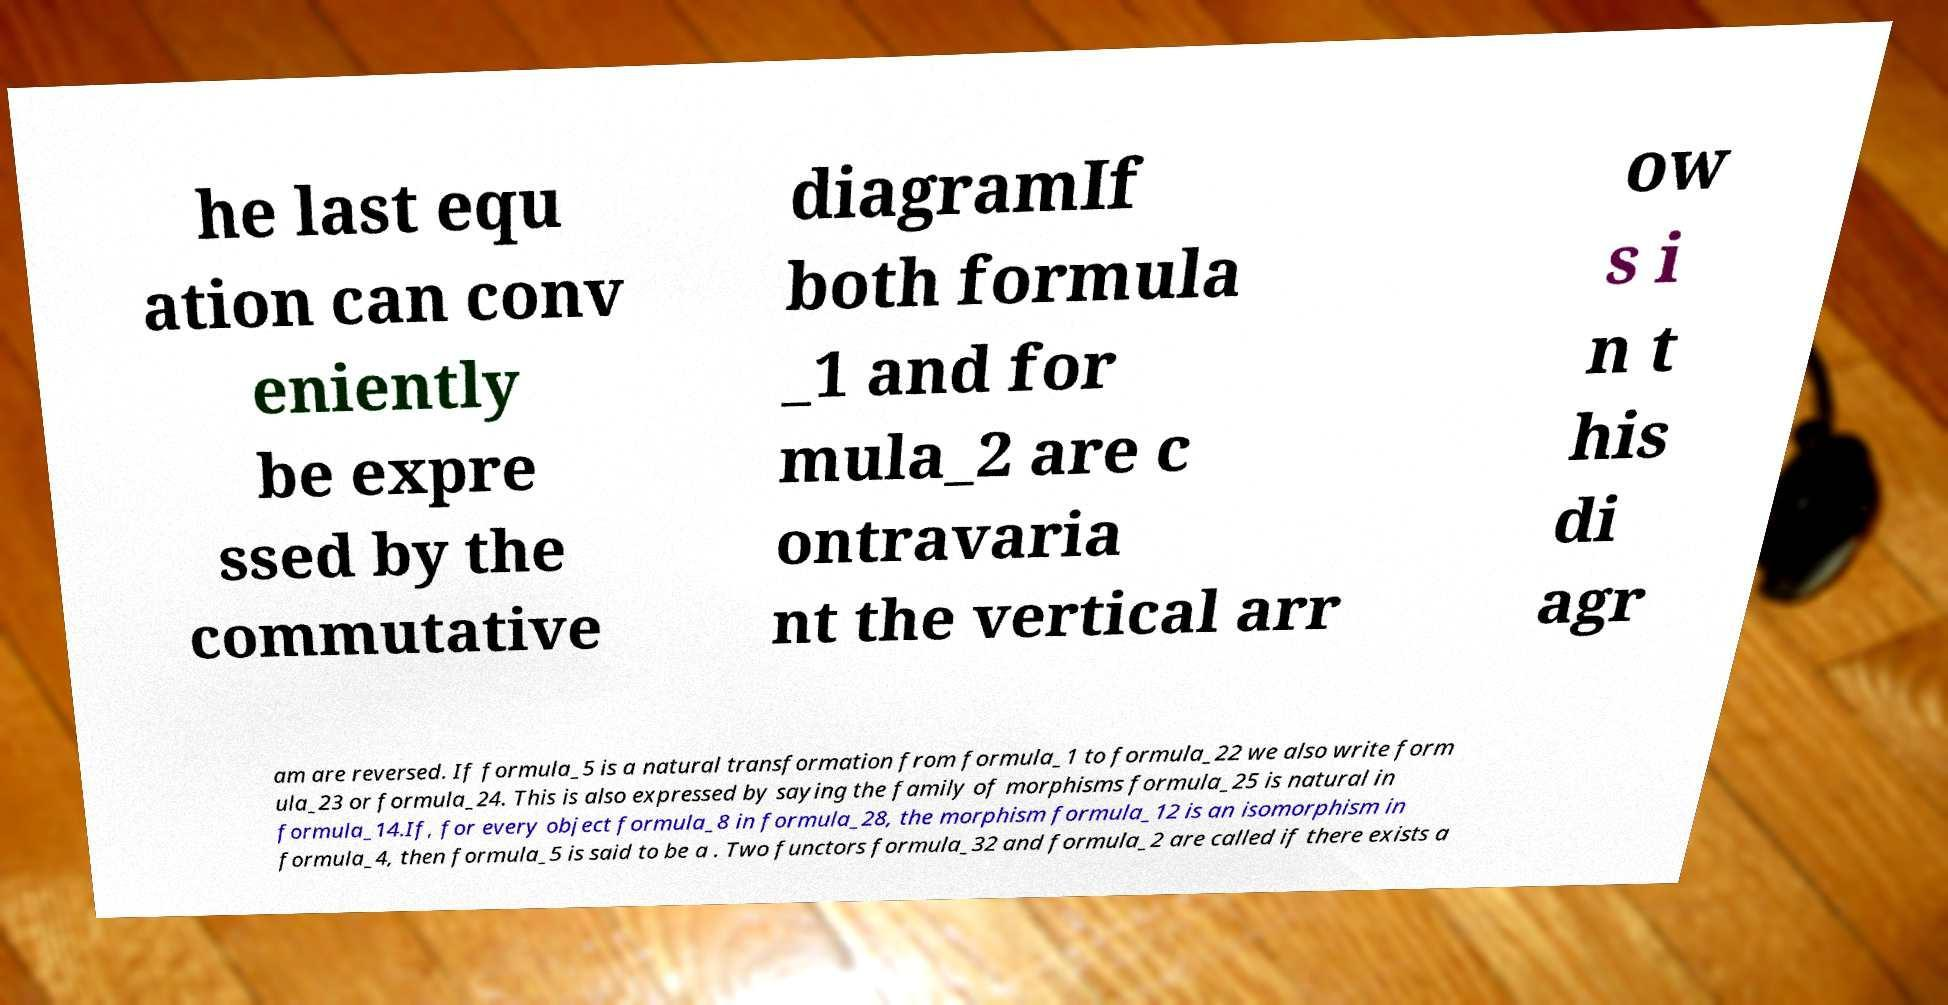Could you extract and type out the text from this image? he last equ ation can conv eniently be expre ssed by the commutative diagramIf both formula _1 and for mula_2 are c ontravaria nt the vertical arr ow s i n t his di agr am are reversed. If formula_5 is a natural transformation from formula_1 to formula_22 we also write form ula_23 or formula_24. This is also expressed by saying the family of morphisms formula_25 is natural in formula_14.If, for every object formula_8 in formula_28, the morphism formula_12 is an isomorphism in formula_4, then formula_5 is said to be a . Two functors formula_32 and formula_2 are called if there exists a 